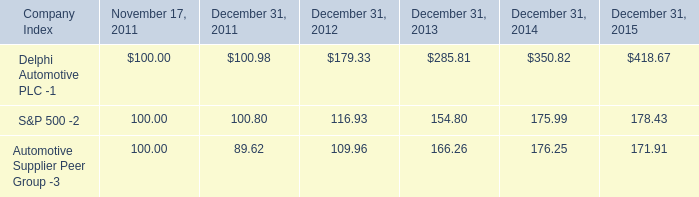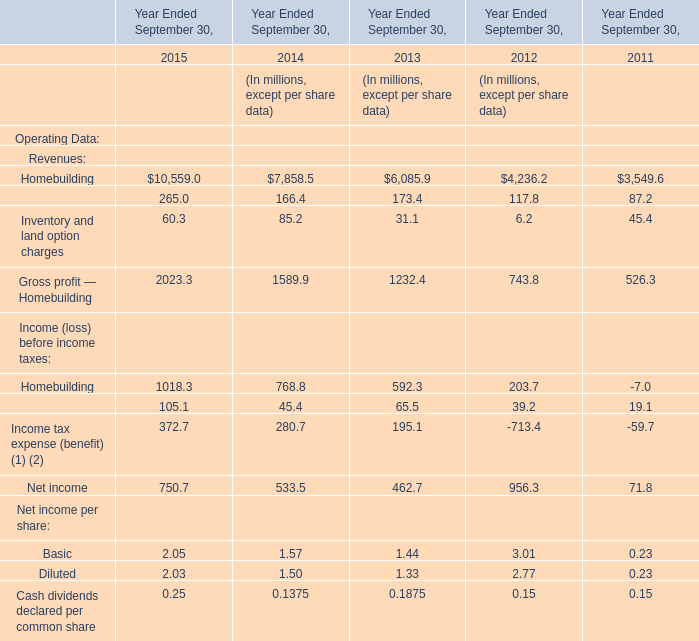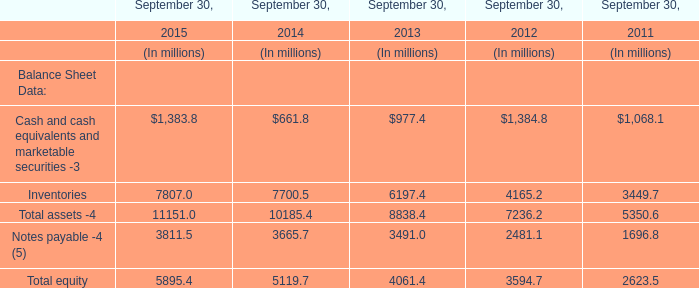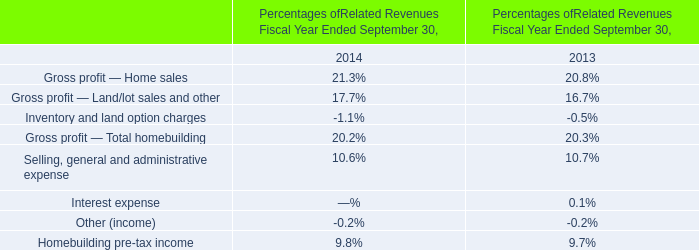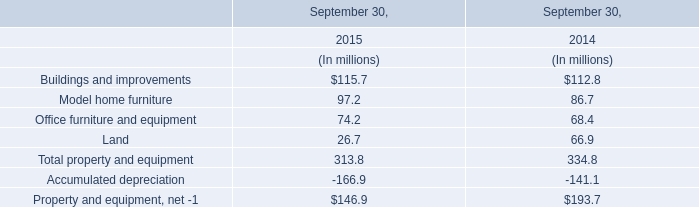What was the average value of the Homebuilding and Financial Services of Income (loss) before income taxes in the years where Homebuilding of Revenues is positive? (in million) 
Computations: ((1018.3 + 105.1) / 2)
Answer: 561.7. 